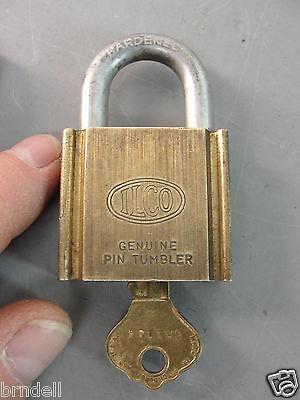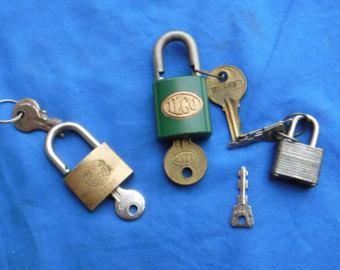The first image is the image on the left, the second image is the image on the right. Evaluate the accuracy of this statement regarding the images: "There are at least two locks with their keys shown in one of the images.". Is it true? Answer yes or no. Yes. The first image is the image on the left, the second image is the image on the right. For the images shown, is this caption "A key is alongside a lock, and no keys are inserted in a lock, in one image." true? Answer yes or no. No. The first image is the image on the left, the second image is the image on the right. Given the left and right images, does the statement "There is one key and one lock in the left image." hold true? Answer yes or no. Yes. 